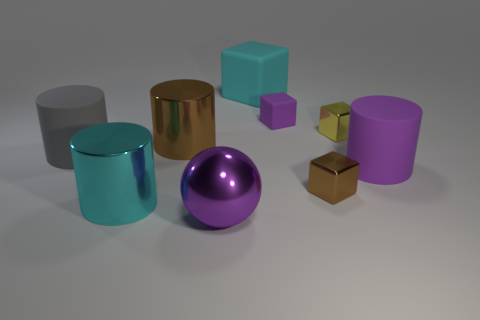What number of blocks have the same color as the big shiny ball?
Your answer should be compact. 1. There is a rubber cube that is right of the cyan rubber block; is its color the same as the large cylinder on the right side of the big purple ball?
Your answer should be very brief. Yes. How many other objects are there of the same color as the big sphere?
Give a very brief answer. 2. Is the material of the big cylinder that is on the left side of the cyan shiny object the same as the cyan block?
Offer a terse response. Yes. There is a large brown metallic cylinder; are there any small yellow shiny cubes to the right of it?
Provide a short and direct response. Yes. There is a cube that is in front of the large metallic thing that is behind the cyan thing that is in front of the big cyan rubber block; what color is it?
Your answer should be very brief. Brown. There is a rubber thing that is the same size as the brown shiny block; what shape is it?
Make the answer very short. Cube. Are there more large blue metallic cylinders than gray things?
Ensure brevity in your answer.  No. Are there any purple things on the left side of the cyan object that is in front of the purple cylinder?
Offer a very short reply. No. What color is the other large matte object that is the same shape as the big purple rubber thing?
Offer a very short reply. Gray. 